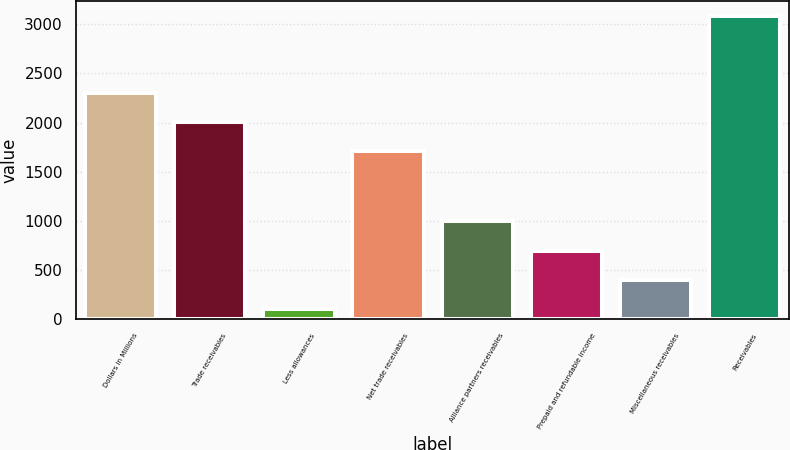Convert chart. <chart><loc_0><loc_0><loc_500><loc_500><bar_chart><fcel>Dollars in Millions<fcel>Trade receivables<fcel>Less allowances<fcel>Net trade receivables<fcel>Alliance partners receivables<fcel>Prepaid and refundable income<fcel>Miscellaneous receivables<fcel>Receivables<nl><fcel>2303.8<fcel>2005.9<fcel>104<fcel>1708<fcel>997.7<fcel>699.8<fcel>401.9<fcel>3083<nl></chart> 